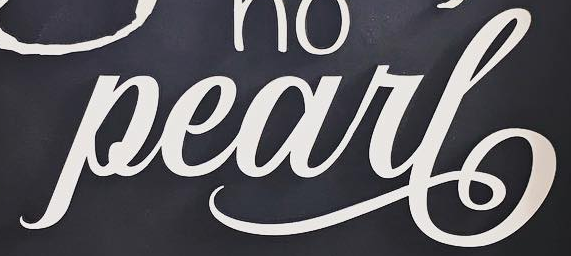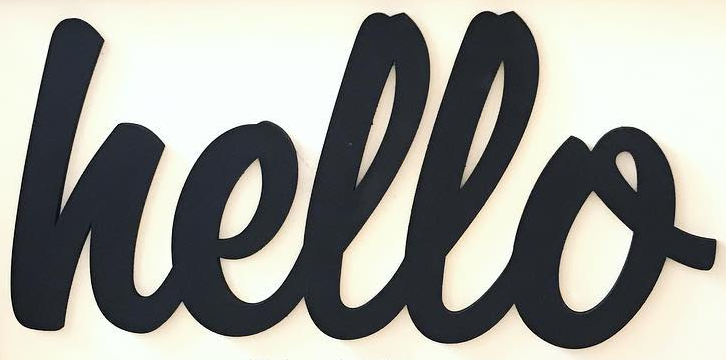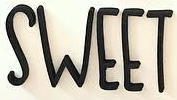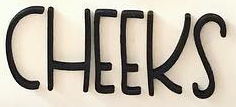Transcribe the words shown in these images in order, separated by a semicolon. Pearl; hello; SWEET; CHEEKS 